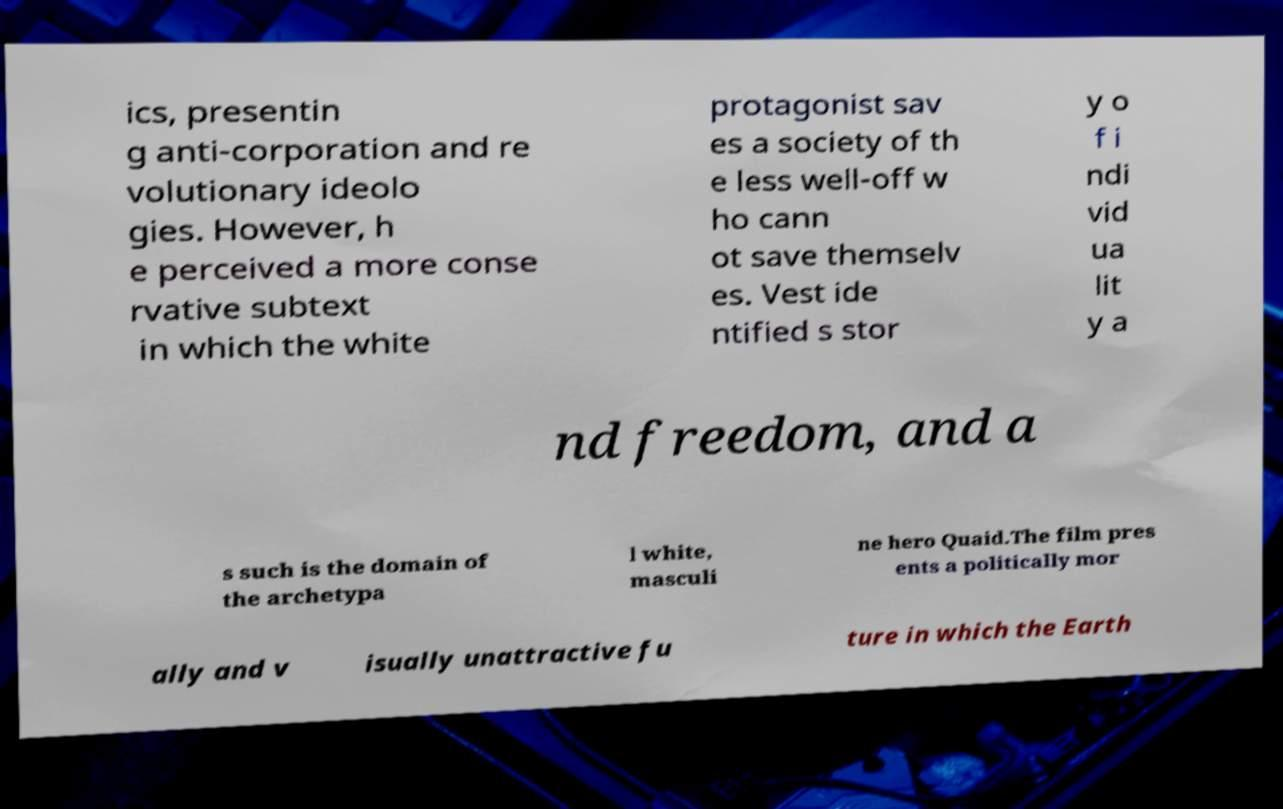Could you extract and type out the text from this image? ics, presentin g anti-corporation and re volutionary ideolo gies. However, h e perceived a more conse rvative subtext in which the white protagonist sav es a society of th e less well-off w ho cann ot save themselv es. Vest ide ntified s stor y o f i ndi vid ua lit y a nd freedom, and a s such is the domain of the archetypa l white, masculi ne hero Quaid.The film pres ents a politically mor ally and v isually unattractive fu ture in which the Earth 